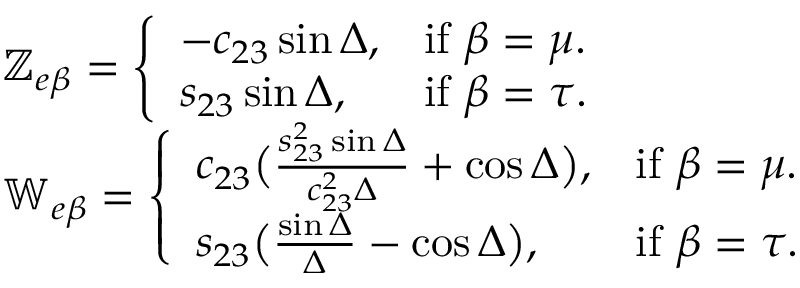<formula> <loc_0><loc_0><loc_500><loc_500>\begin{array} { r l } & { \mathbb { Z } _ { e \beta } = \left \{ \begin{array} { l l } { - c _ { 2 3 } \sin \Delta , } & { i f \ \beta = \mu . } \\ { s _ { 2 3 } \sin \Delta , } & { i f \ \beta = \tau . } \end{array} } \\ & { \mathbb { W } _ { e \beta } = \left \{ \begin{array} { l l } { c _ { 2 3 } \left ( \frac { s _ { 2 3 } ^ { 2 } \sin \Delta } { c _ { 2 3 } ^ { 2 } \Delta } + \cos \Delta \right ) , } & { i f \ \beta = \mu . } \\ { s _ { 2 3 } \left ( \frac { \sin \Delta } { \Delta } - \cos \Delta \right ) , } & { i f \ \beta = \tau . } \end{array} } \end{array}</formula> 